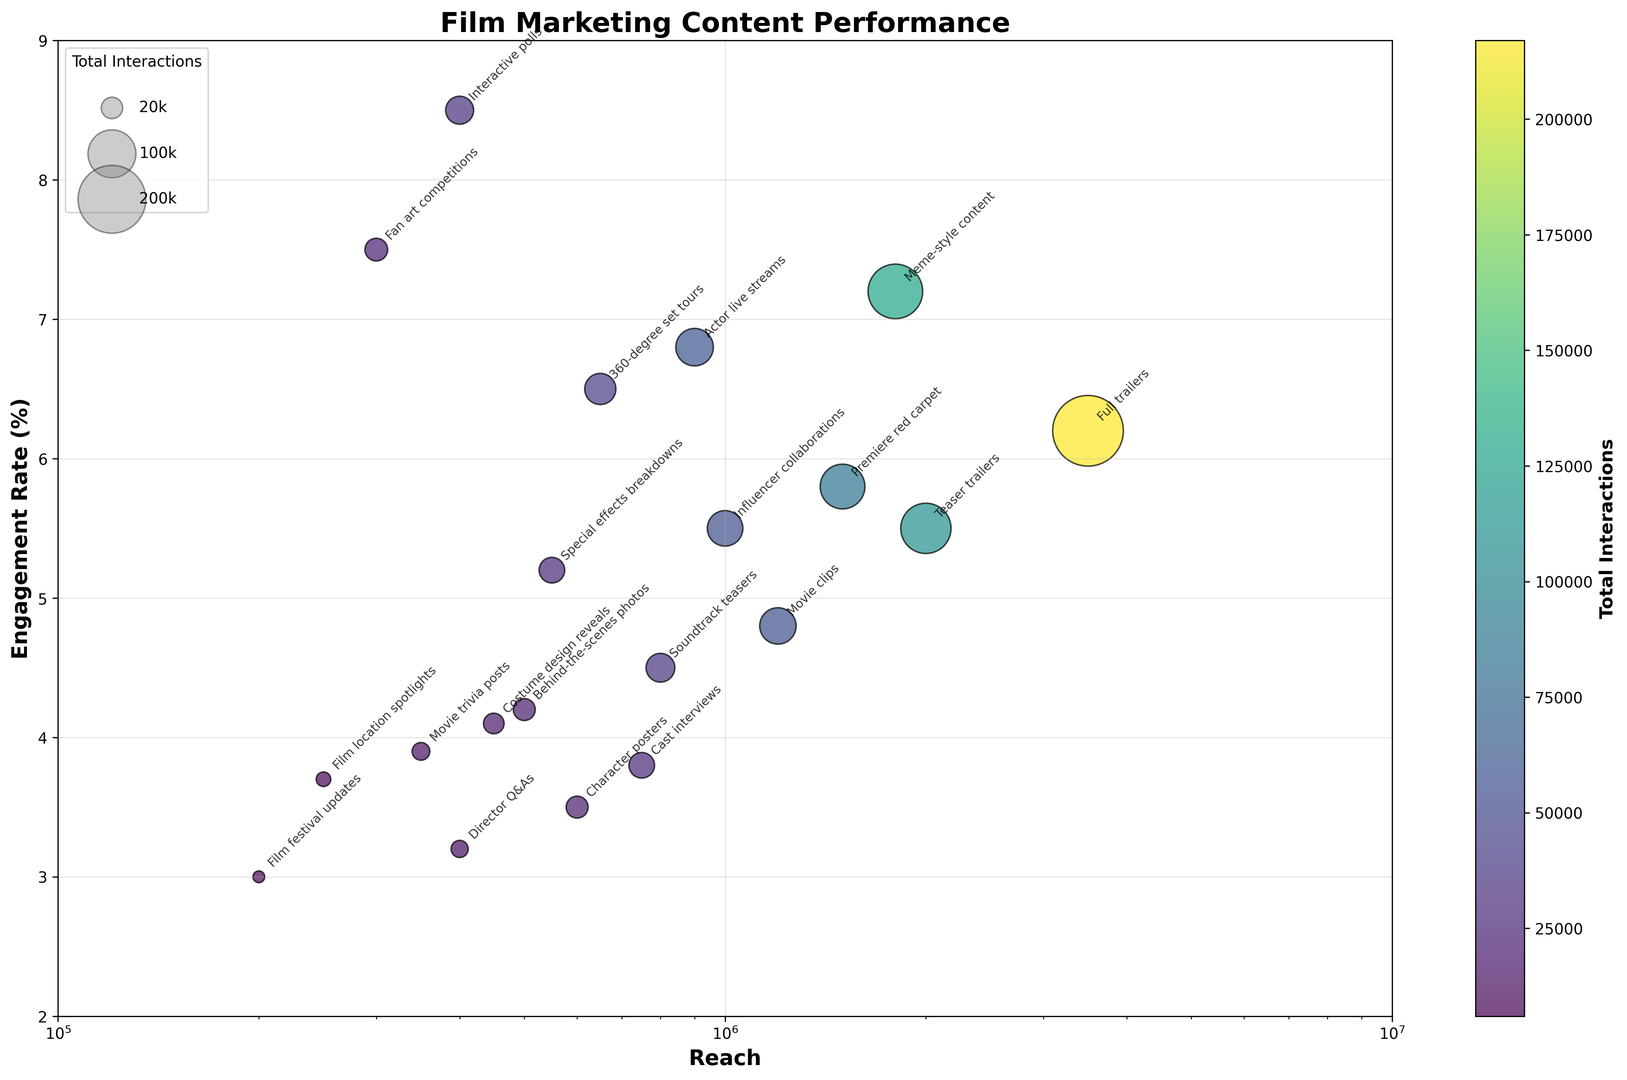Which type of film marketing content has the highest engagement rate? Look for the point on the vertical axis (Engagement Rate) that is the highest. "Interactive polls" has the highest engagement rate at 8.5%.
Answer: Interactive polls What is the reach and total interactions of the film marketing content with the second-highest engagement rate? The second-highest engagement rate is represented by "Fan art competitions" at 7.5%. The corresponding reach is 300,000, and total interactions are 22,500.
Answer: Reach: 300,000, Total Interactions: 22,500 Which content type has the highest total interactions, and what is the engagement rate of that content? Look for the largest bubble. "Full trailers" has the highest total interactions at 217,000. Its engagement rate is 6.2%.
Answer: Full trailers, Engagement Rate: 6.2% Compare the engagement rates and total interactions of "Meme-style content" and "Actor live streams". Which one performs better based on these metrics? "Meme-style content" has an engagement rate of 7.2% and total interactions of 129,600. "Actor live streams" has an engagement rate of 6.8% and total interactions of 61,200. "Meme-style content" performs better in both metrics.
Answer: Meme-style content Calculate the average engagement rate of the three content types with the lowest reach. The three types with the lowest reach are "Film festival updates" (200,000), "Fan art competitions" (300,000), and "Film location spotlights" (250,000). Their engagement rates are 3.0%, 7.5%, and 3.7% respectively. The average is (3.0 + 7.5 + 3.7) / 3 = 4.7%.
Answer: 4.7% Which type of content has a higher reach, "Character posters" or "Behind-the-scenes photos"? "Character posters" has a reach of 600,000 while "Behind-the-scenes photos" has a reach of 500,000. Therefore, "Character posters" has a higher reach.
Answer: Character posters Identify the content type with a reach of around 2,000,000 and specify its engagement rate and total interactions. The content type with a reach close to 2,000,000 is "Teaser trailers". Its engagement rate is 5.5%, and total interactions are 110,000.
Answer: Teaser trailers, Engagement Rate: 5.5%, Total Interactions: 110,000 How many types of content have an engagement rate greater than 6.0%? Find the points above the 6.0% mark on the vertical axis. The types are "Fan art competitions" (7.5%), "Premiere red carpet" (5.8%), "Actor live streams" (6.8%), "Meme-style content" (7.2%), and "Interactive polls" (8.5%). There are 5 such content types.
Answer: 5 Which content type has a total interactions value closest to 50,000? Look for the bubble with a size closest to 50,000 in total interactions. "Influencer collaborations" has total interactions of 55,000, which is closest to 50,000.
Answer: Influencer collaborations 